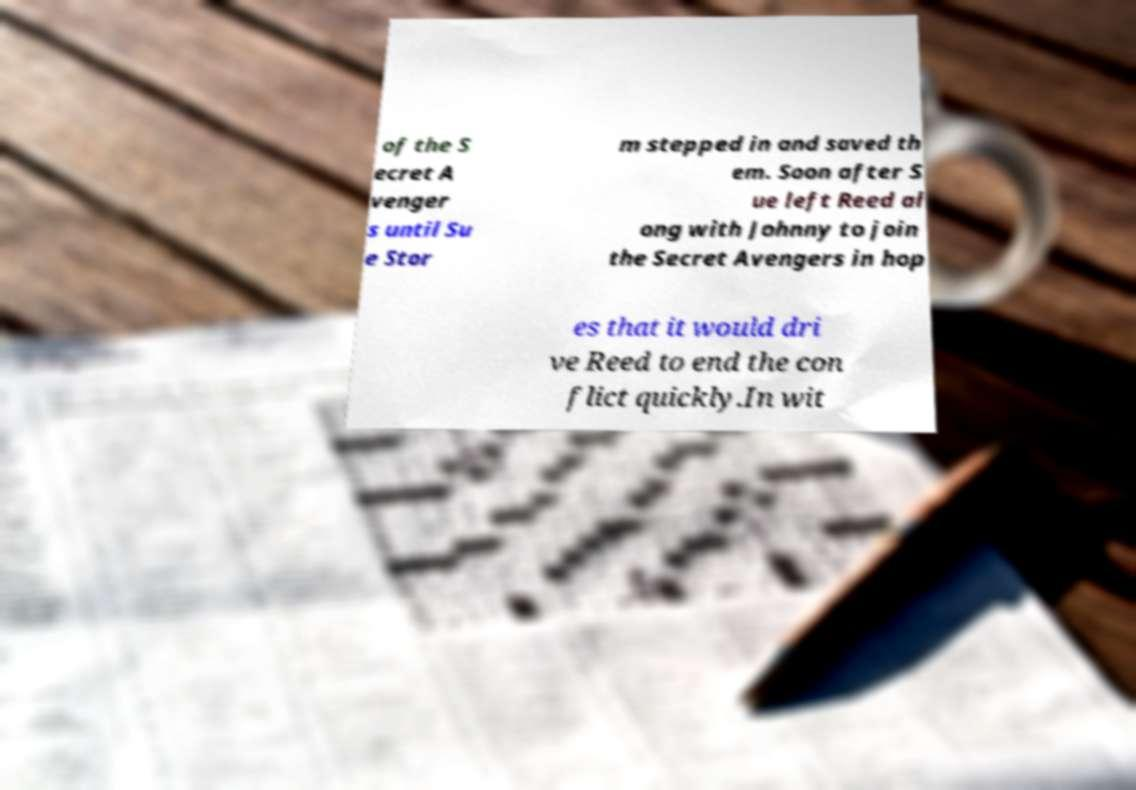Could you extract and type out the text from this image? of the S ecret A venger s until Su e Stor m stepped in and saved th em. Soon after S ue left Reed al ong with Johnny to join the Secret Avengers in hop es that it would dri ve Reed to end the con flict quickly.In wit 